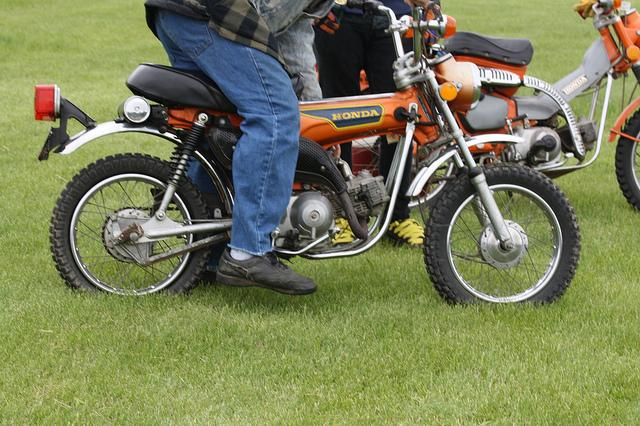What type of road are the small motorcycles created for?

Choices:
A) roadways
B) highways
C) bike lanes
D) trails trails 